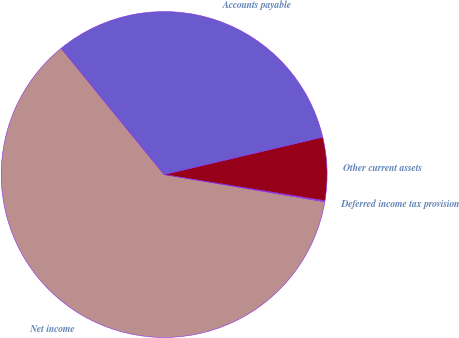<chart> <loc_0><loc_0><loc_500><loc_500><pie_chart><fcel>Net income<fcel>Deferred income tax provision<fcel>Other current assets<fcel>Accounts payable<nl><fcel>61.44%<fcel>0.11%<fcel>6.25%<fcel>32.2%<nl></chart> 